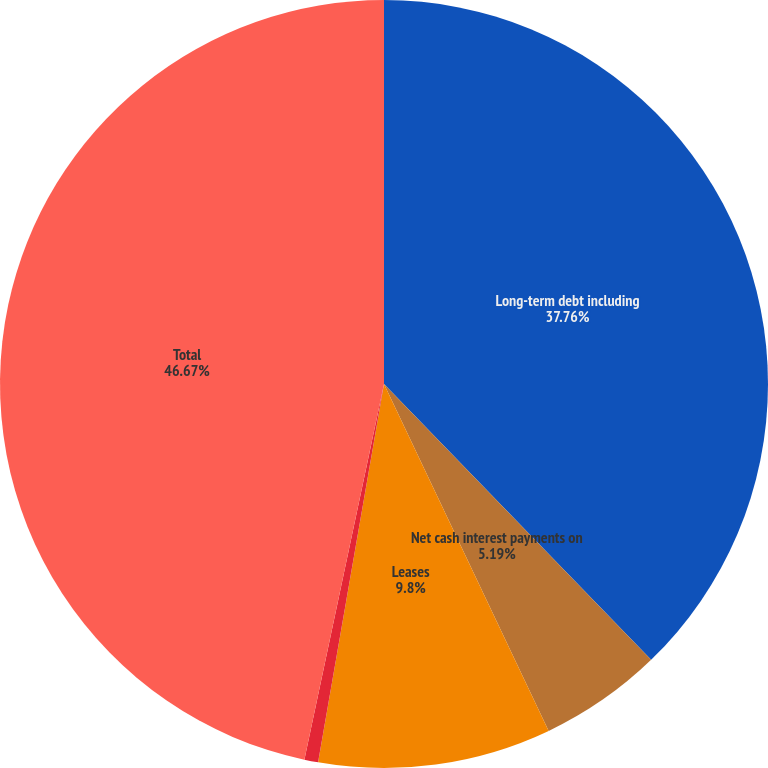Convert chart. <chart><loc_0><loc_0><loc_500><loc_500><pie_chart><fcel>Long-term debt including<fcel>Net cash interest payments on<fcel>Leases<fcel>Purchase obligations (2)<fcel>Total<nl><fcel>37.76%<fcel>5.19%<fcel>9.8%<fcel>0.58%<fcel>46.68%<nl></chart> 